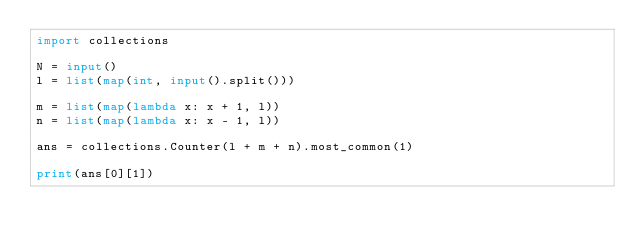<code> <loc_0><loc_0><loc_500><loc_500><_Python_>import collections

N = input()
l = list(map(int, input().split()))

m = list(map(lambda x: x + 1, l))
n = list(map(lambda x: x - 1, l))

ans = collections.Counter(l + m + n).most_common(1)

print(ans[0][1])</code> 